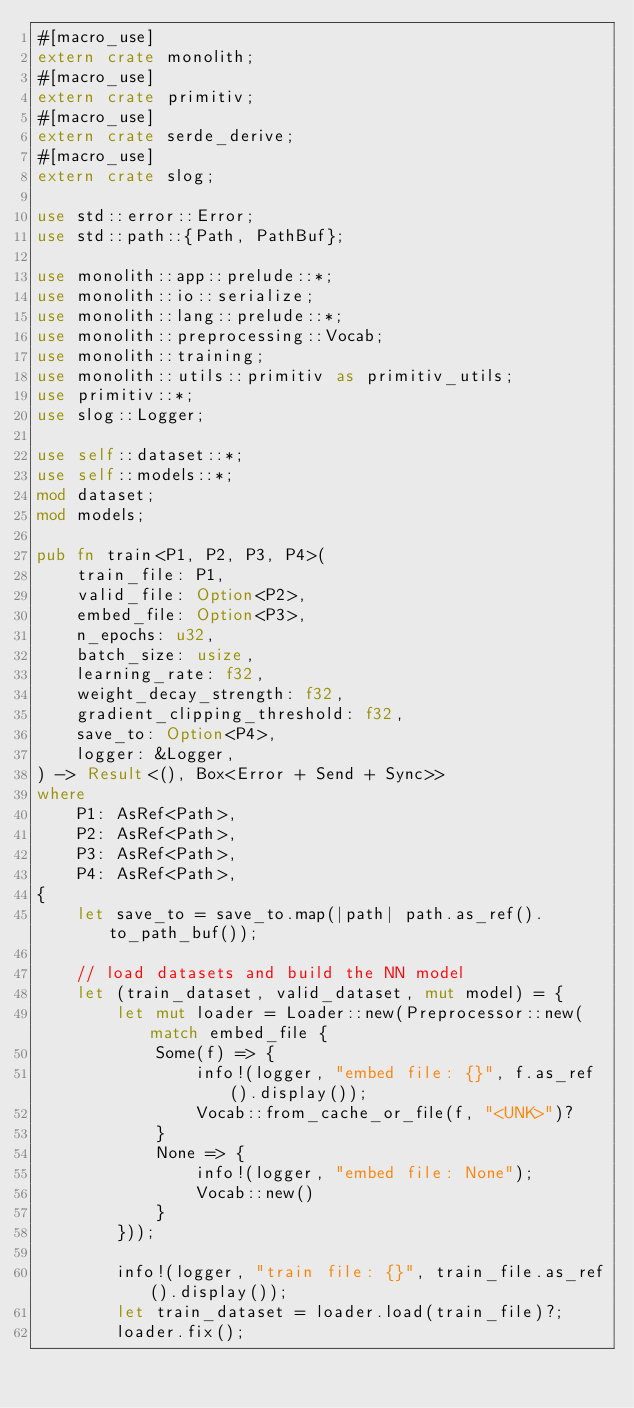Convert code to text. <code><loc_0><loc_0><loc_500><loc_500><_Rust_>#[macro_use]
extern crate monolith;
#[macro_use]
extern crate primitiv;
#[macro_use]
extern crate serde_derive;
#[macro_use]
extern crate slog;

use std::error::Error;
use std::path::{Path, PathBuf};

use monolith::app::prelude::*;
use monolith::io::serialize;
use monolith::lang::prelude::*;
use monolith::preprocessing::Vocab;
use monolith::training;
use monolith::utils::primitiv as primitiv_utils;
use primitiv::*;
use slog::Logger;

use self::dataset::*;
use self::models::*;
mod dataset;
mod models;

pub fn train<P1, P2, P3, P4>(
    train_file: P1,
    valid_file: Option<P2>,
    embed_file: Option<P3>,
    n_epochs: u32,
    batch_size: usize,
    learning_rate: f32,
    weight_decay_strength: f32,
    gradient_clipping_threshold: f32,
    save_to: Option<P4>,
    logger: &Logger,
) -> Result<(), Box<Error + Send + Sync>>
where
    P1: AsRef<Path>,
    P2: AsRef<Path>,
    P3: AsRef<Path>,
    P4: AsRef<Path>,
{
    let save_to = save_to.map(|path| path.as_ref().to_path_buf());

    // load datasets and build the NN model
    let (train_dataset, valid_dataset, mut model) = {
        let mut loader = Loader::new(Preprocessor::new(match embed_file {
            Some(f) => {
                info!(logger, "embed file: {}", f.as_ref().display());
                Vocab::from_cache_or_file(f, "<UNK>")?
            }
            None => {
                info!(logger, "embed file: None");
                Vocab::new()
            }
        }));

        info!(logger, "train file: {}", train_file.as_ref().display());
        let train_dataset = loader.load(train_file)?;
        loader.fix();</code> 